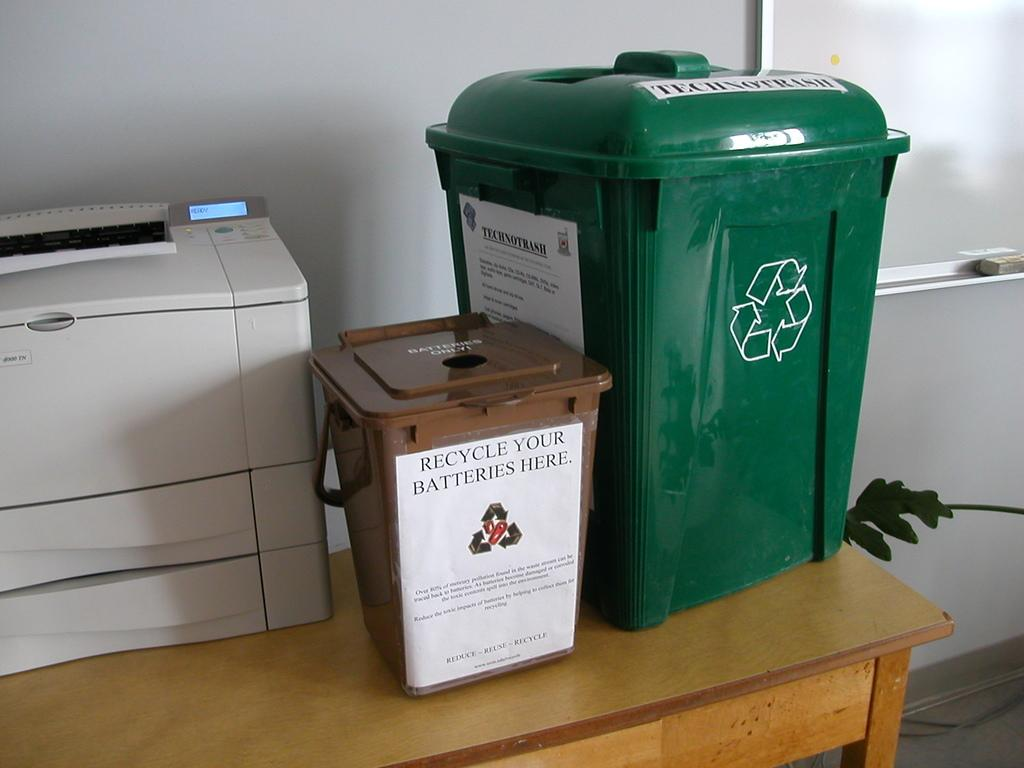<image>
Provide a brief description of the given image. Green garbage can next to a box which says it's for recycling batteries. 